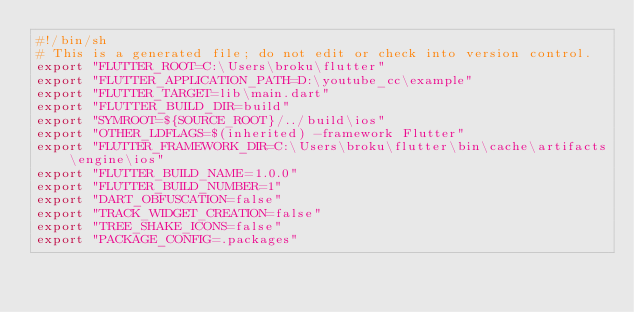Convert code to text. <code><loc_0><loc_0><loc_500><loc_500><_Bash_>#!/bin/sh
# This is a generated file; do not edit or check into version control.
export "FLUTTER_ROOT=C:\Users\broku\flutter"
export "FLUTTER_APPLICATION_PATH=D:\youtube_cc\example"
export "FLUTTER_TARGET=lib\main.dart"
export "FLUTTER_BUILD_DIR=build"
export "SYMROOT=${SOURCE_ROOT}/../build\ios"
export "OTHER_LDFLAGS=$(inherited) -framework Flutter"
export "FLUTTER_FRAMEWORK_DIR=C:\Users\broku\flutter\bin\cache\artifacts\engine\ios"
export "FLUTTER_BUILD_NAME=1.0.0"
export "FLUTTER_BUILD_NUMBER=1"
export "DART_OBFUSCATION=false"
export "TRACK_WIDGET_CREATION=false"
export "TREE_SHAKE_ICONS=false"
export "PACKAGE_CONFIG=.packages"
</code> 